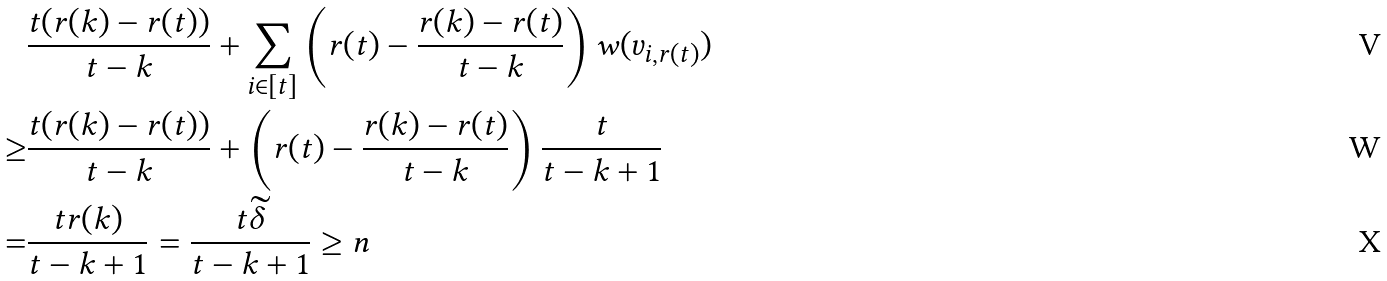Convert formula to latex. <formula><loc_0><loc_0><loc_500><loc_500>& \frac { t ( r ( k ) - r ( t ) ) } { t - k } + \sum _ { i \in [ t ] } \left ( r ( t ) - \frac { r ( k ) - r ( t ) } { t - k } \right ) w ( v _ { i , r ( t ) } ) \\ \geq & \frac { t ( r ( k ) - r ( t ) ) } { t - k } + \left ( r ( t ) - \frac { r ( k ) - r ( t ) } { t - k } \right ) \frac { t } { t - k + 1 } \\ = & \frac { t r ( k ) } { t - k + 1 } = \frac { t \widetilde { \delta } } { t - k + 1 } \geq n</formula> 